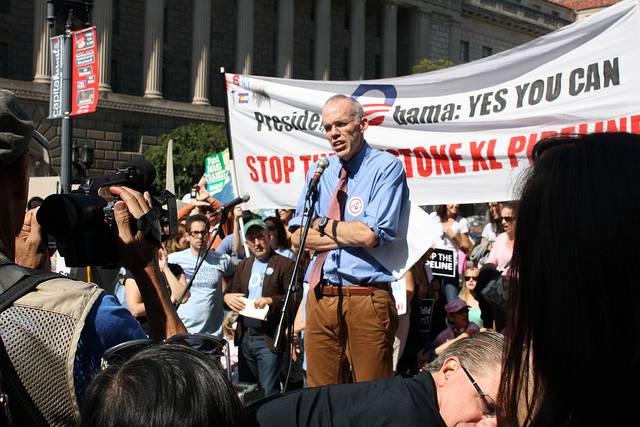Please transcribe the text information in this image. Preside hama YES YOU CAN capital ELINE PI KL STONE STOP 